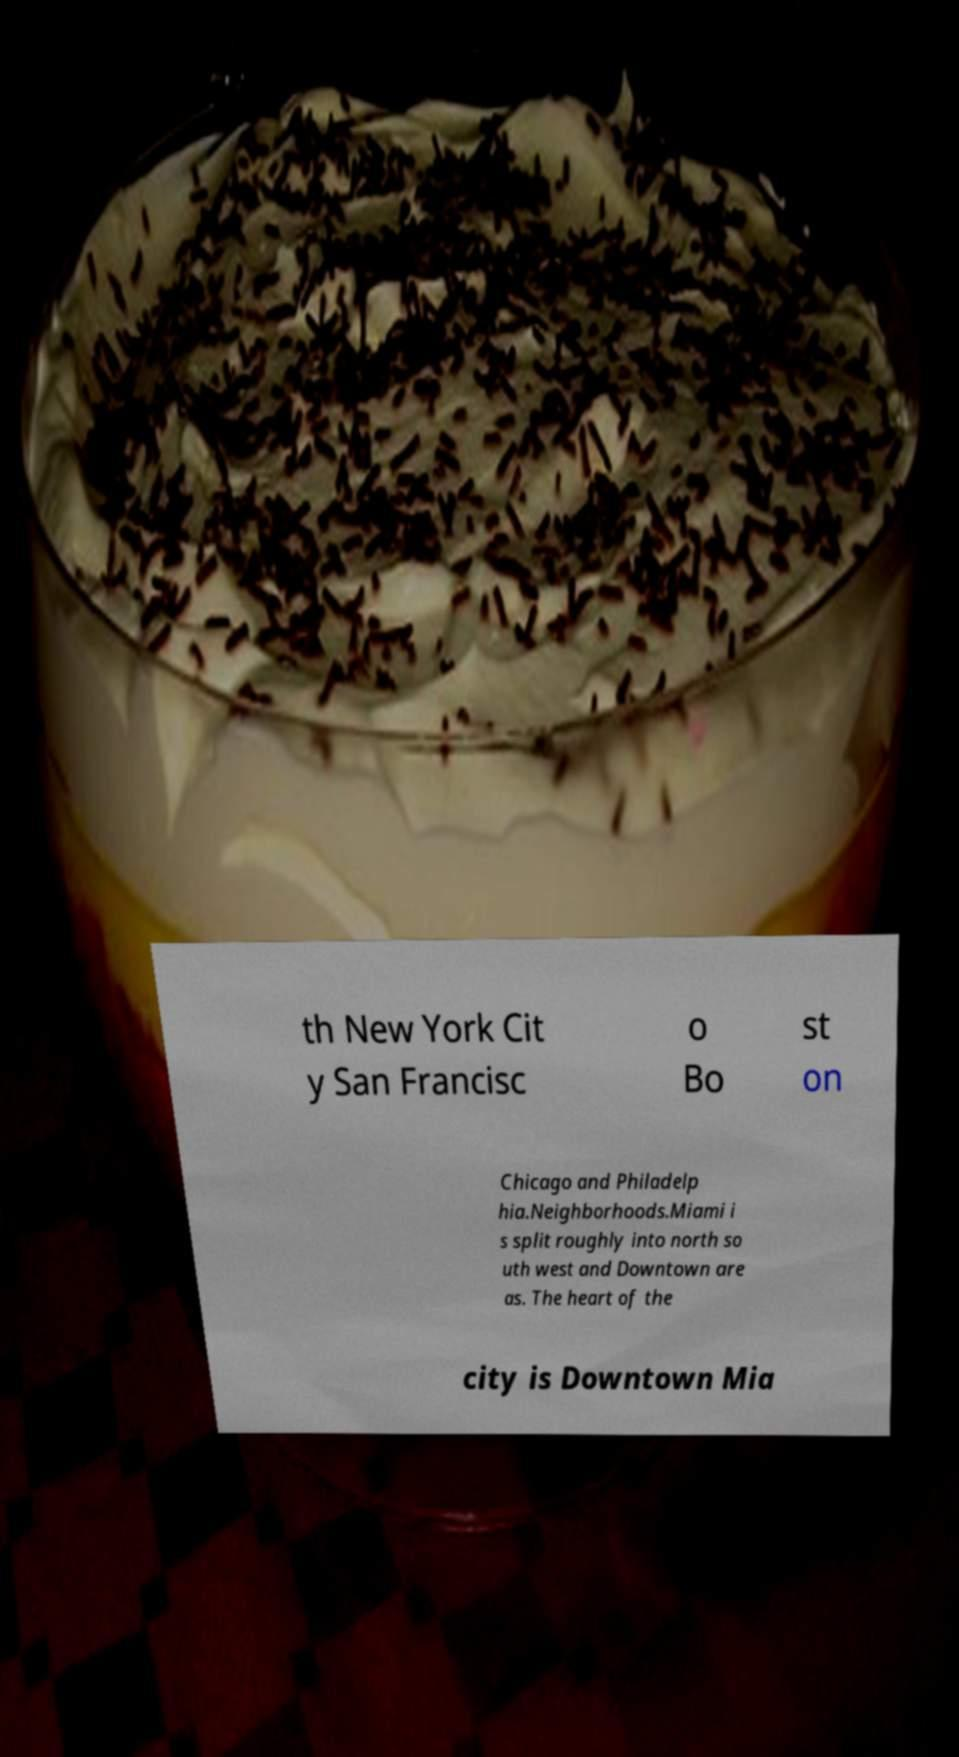Please identify and transcribe the text found in this image. th New York Cit y San Francisc o Bo st on Chicago and Philadelp hia.Neighborhoods.Miami i s split roughly into north so uth west and Downtown are as. The heart of the city is Downtown Mia 